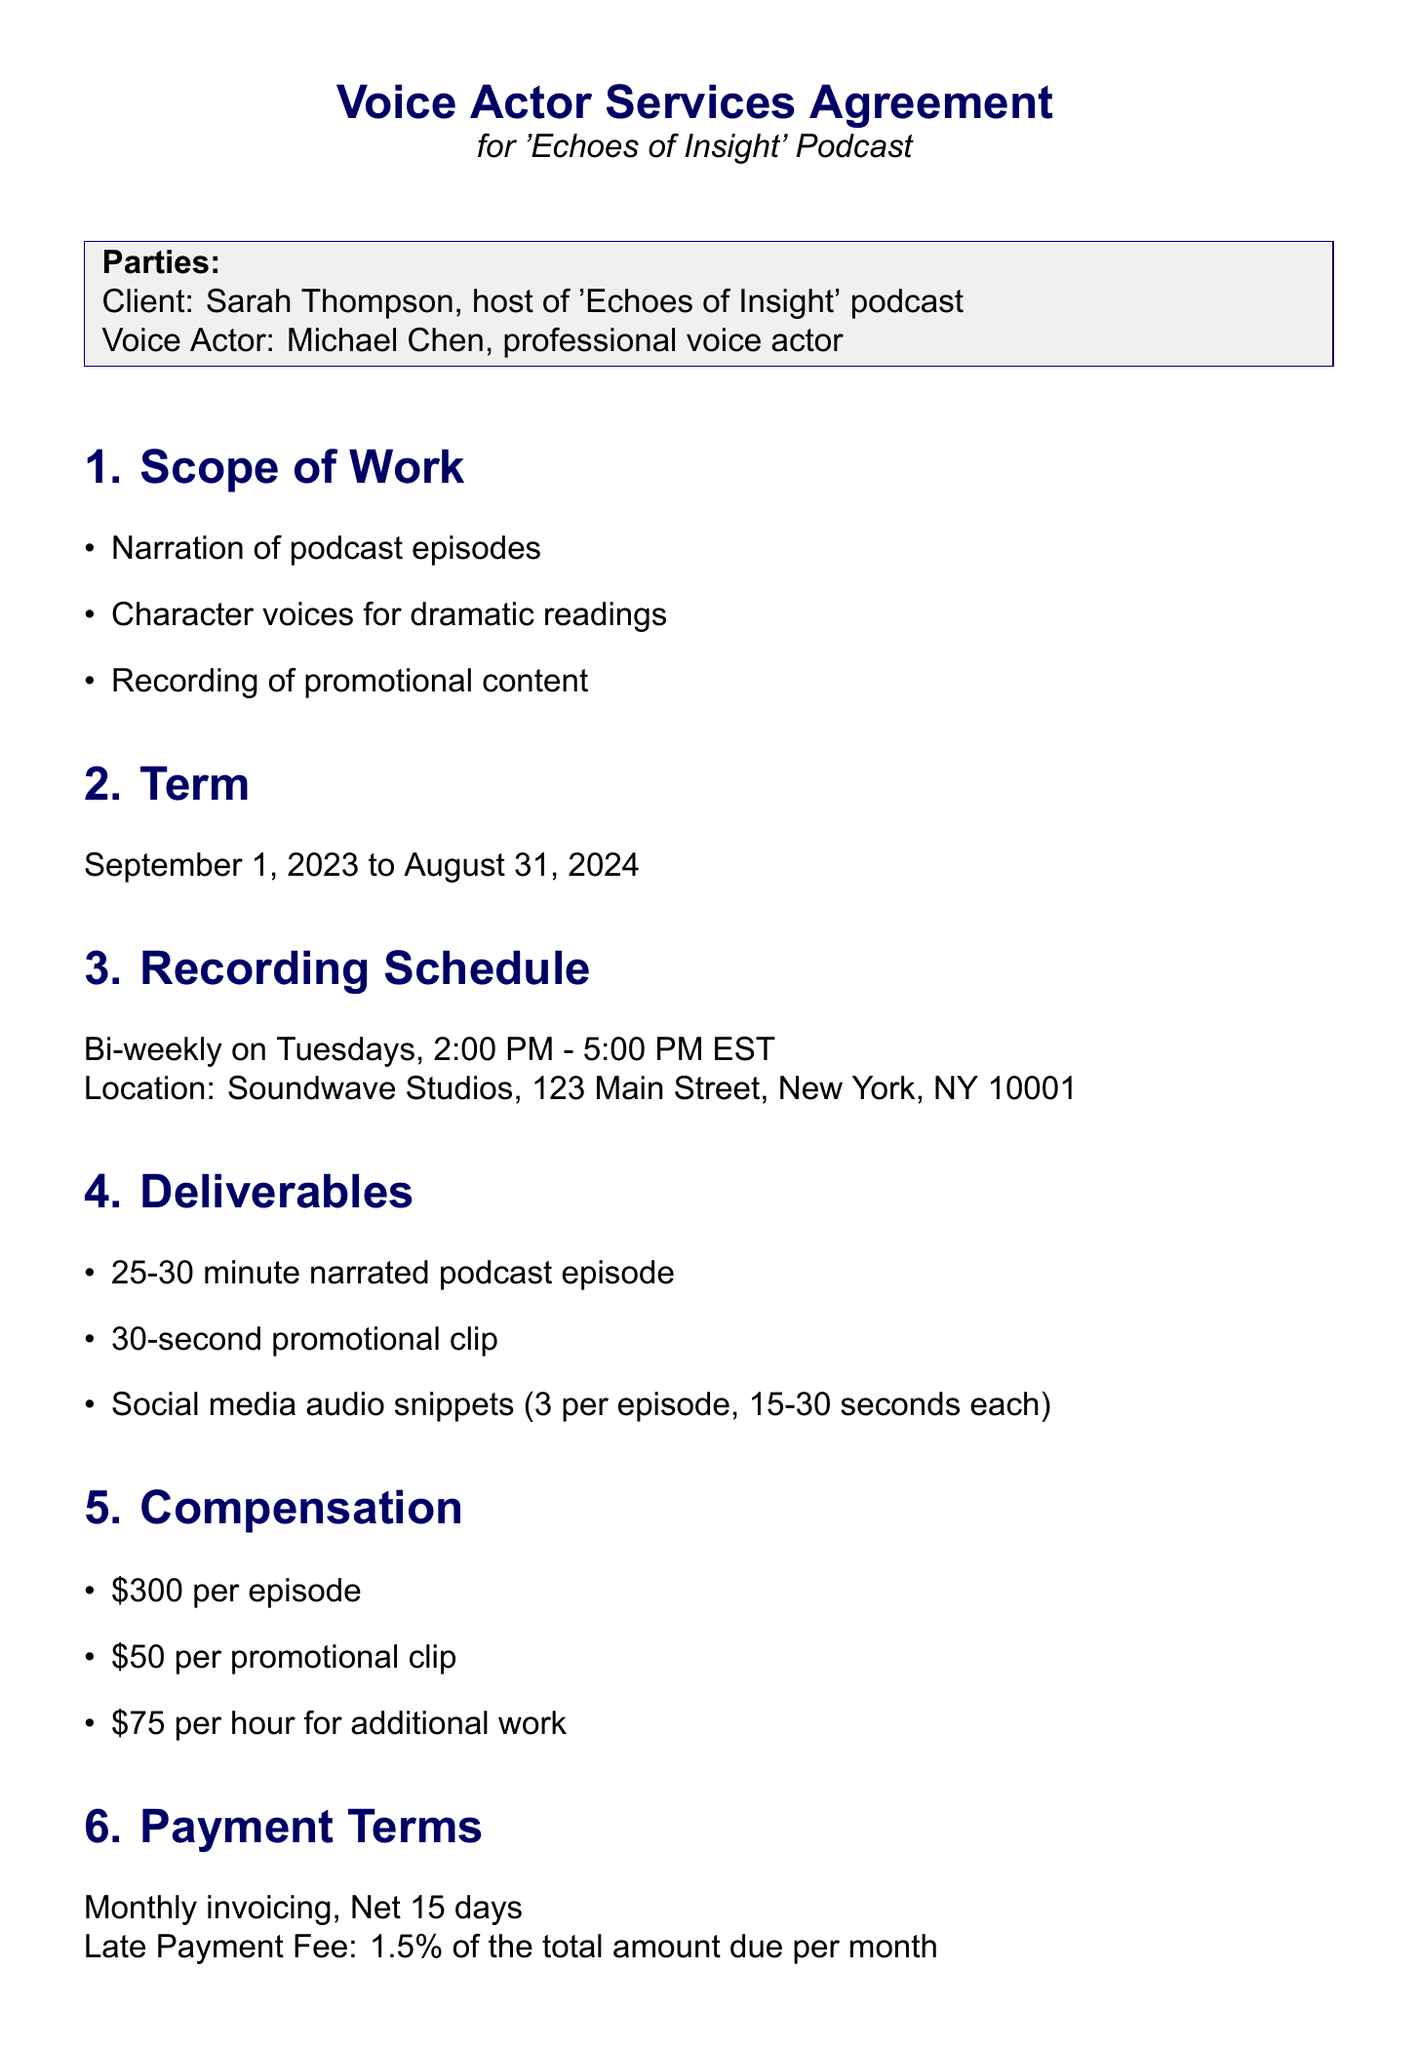What is the title of the contract? The title of the contract is specified at the beginning of the document as "Voice Actor Services Agreement for 'Echoes of Insight' Podcast."
Answer: Voice Actor Services Agreement for 'Echoes of Insight' Podcast Who is the client? The document specifies the client as Sarah Thompson, who is the host of the podcast.
Answer: Sarah Thompson What is the frequency of the recording schedule? The recording schedule indicates a frequency specified in the document.
Answer: Bi-weekly What is the rate per episode? The document outlines the compensation for different services, including the rate per episode.
Answer: $300 What is the cancellation fee? The cancellation policy provides a specific amount for the cancellation fee within the document.
Answer: 50% of the agreed rate for the cancelled session What is the duration of the contract? The term section of the document specifies the start and end dates of the contract.
Answer: September 1, 2023 to August 31, 2024 What accommodations are provided for accessibility? The document states specific client needs for accessibility regarding script materials and studio accommodations.
Answer: Scripts provided in Braille or screen-reader compatible format How many social media audio snippets are required per episode? The document mentions the number of snippets required in the deliverables section.
Answer: 3 per episode What is the payment due date after invoicing? The payment terms section specifies the time frame for payment after invoicing.
Answer: Net 15 days 